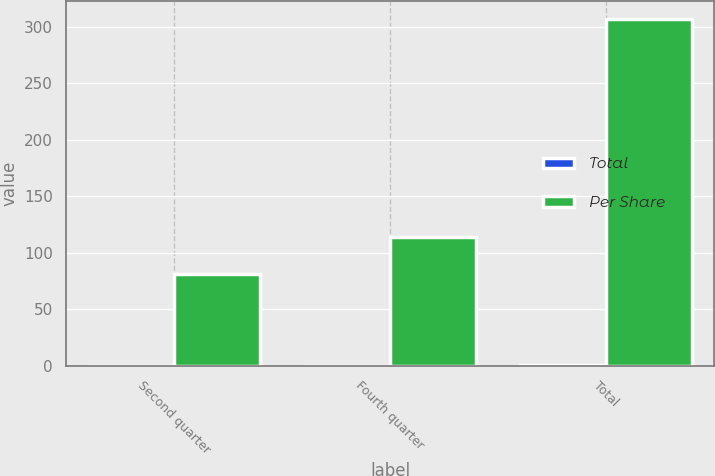Convert chart to OTSL. <chart><loc_0><loc_0><loc_500><loc_500><stacked_bar_chart><ecel><fcel>Second quarter<fcel>Fourth quarter<fcel>Total<nl><fcel>Total<fcel>0.05<fcel>0.07<fcel>0.19<nl><fcel>Per Share<fcel>81<fcel>114<fcel>307<nl></chart> 